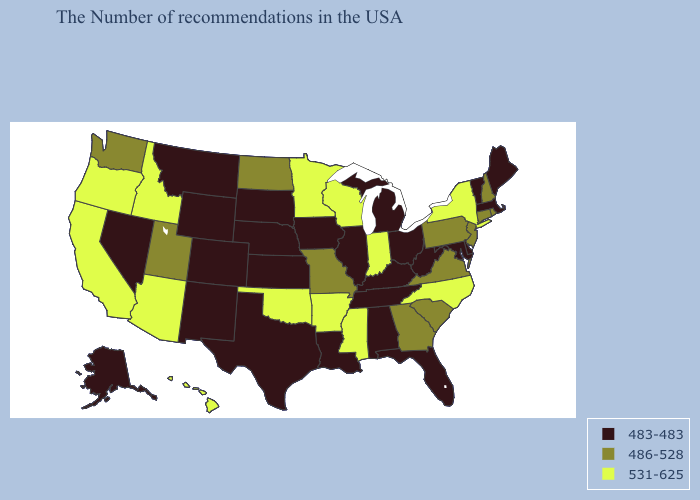What is the value of Oklahoma?
Be succinct. 531-625. Name the states that have a value in the range 531-625?
Answer briefly. New York, North Carolina, Indiana, Wisconsin, Mississippi, Arkansas, Minnesota, Oklahoma, Arizona, Idaho, California, Oregon, Hawaii. Does Mississippi have the same value as Oregon?
Give a very brief answer. Yes. What is the highest value in the MidWest ?
Keep it brief. 531-625. What is the lowest value in the USA?
Quick response, please. 483-483. Among the states that border Pennsylvania , which have the lowest value?
Keep it brief. Delaware, Maryland, West Virginia, Ohio. Which states have the highest value in the USA?
Give a very brief answer. New York, North Carolina, Indiana, Wisconsin, Mississippi, Arkansas, Minnesota, Oklahoma, Arizona, Idaho, California, Oregon, Hawaii. What is the highest value in states that border Texas?
Concise answer only. 531-625. What is the value of Maine?
Answer briefly. 483-483. What is the value of Maine?
Answer briefly. 483-483. What is the value of Montana?
Write a very short answer. 483-483. Name the states that have a value in the range 486-528?
Write a very short answer. Rhode Island, New Hampshire, Connecticut, New Jersey, Pennsylvania, Virginia, South Carolina, Georgia, Missouri, North Dakota, Utah, Washington. Does Utah have a lower value than Pennsylvania?
Keep it brief. No. Which states have the lowest value in the South?
Write a very short answer. Delaware, Maryland, West Virginia, Florida, Kentucky, Alabama, Tennessee, Louisiana, Texas. Among the states that border Oklahoma , which have the highest value?
Concise answer only. Arkansas. 